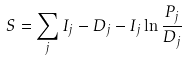<formula> <loc_0><loc_0><loc_500><loc_500>S = \sum _ { j } { I _ { j } - D _ { j } - I _ { j } \ln { \frac { P _ { j } } { D _ { j } } } }</formula> 